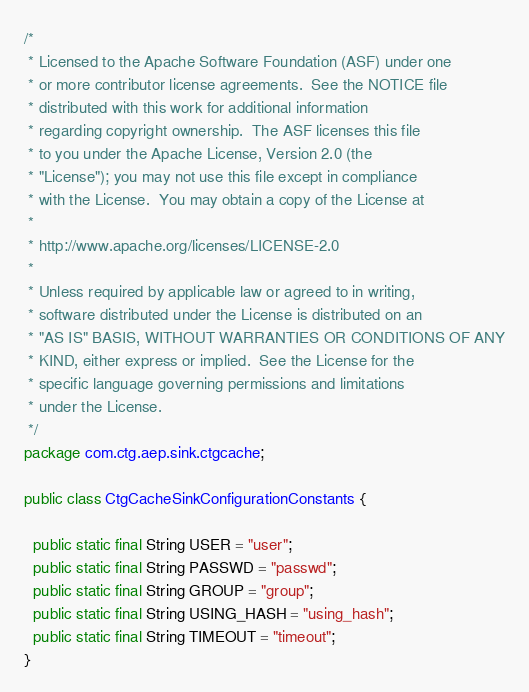Convert code to text. <code><loc_0><loc_0><loc_500><loc_500><_Java_>/*
 * Licensed to the Apache Software Foundation (ASF) under one
 * or more contributor license agreements.  See the NOTICE file
 * distributed with this work for additional information
 * regarding copyright ownership.  The ASF licenses this file
 * to you under the Apache License, Version 2.0 (the
 * "License"); you may not use this file except in compliance
 * with the License.  You may obtain a copy of the License at
 *
 * http://www.apache.org/licenses/LICENSE-2.0
 *
 * Unless required by applicable law or agreed to in writing,
 * software distributed under the License is distributed on an
 * "AS IS" BASIS, WITHOUT WARRANTIES OR CONDITIONS OF ANY
 * KIND, either express or implied.  See the License for the
 * specific language governing permissions and limitations
 * under the License.
 */
package com.ctg.aep.sink.ctgcache;

public class CtgCacheSinkConfigurationConstants {

  public static final String USER = "user";
  public static final String PASSWD = "passwd";
  public static final String GROUP = "group";
  public static final String USING_HASH = "using_hash";
  public static final String TIMEOUT = "timeout";
}
</code> 